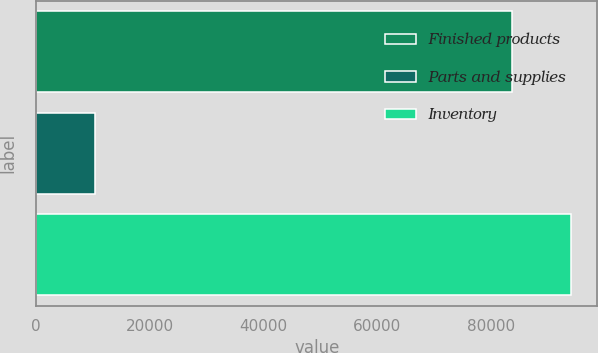Convert chart to OTSL. <chart><loc_0><loc_0><loc_500><loc_500><bar_chart><fcel>Finished products<fcel>Parts and supplies<fcel>Inventory<nl><fcel>83637<fcel>10359<fcel>93996<nl></chart> 